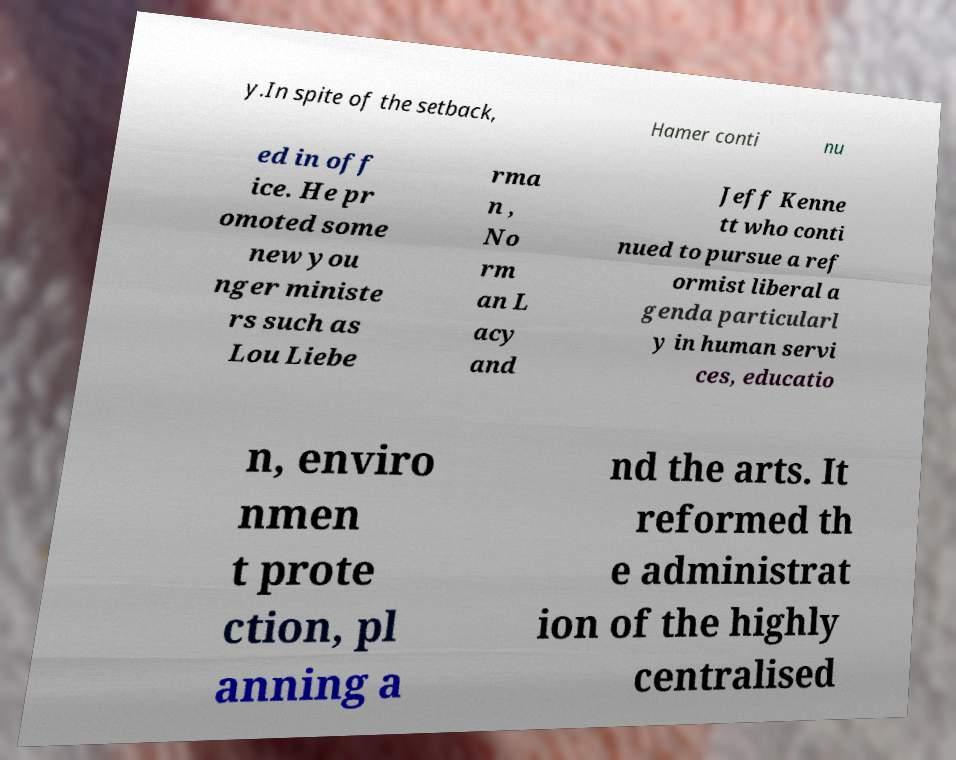Could you extract and type out the text from this image? y.In spite of the setback, Hamer conti nu ed in off ice. He pr omoted some new you nger ministe rs such as Lou Liebe rma n , No rm an L acy and Jeff Kenne tt who conti nued to pursue a ref ormist liberal a genda particularl y in human servi ces, educatio n, enviro nmen t prote ction, pl anning a nd the arts. It reformed th e administrat ion of the highly centralised 